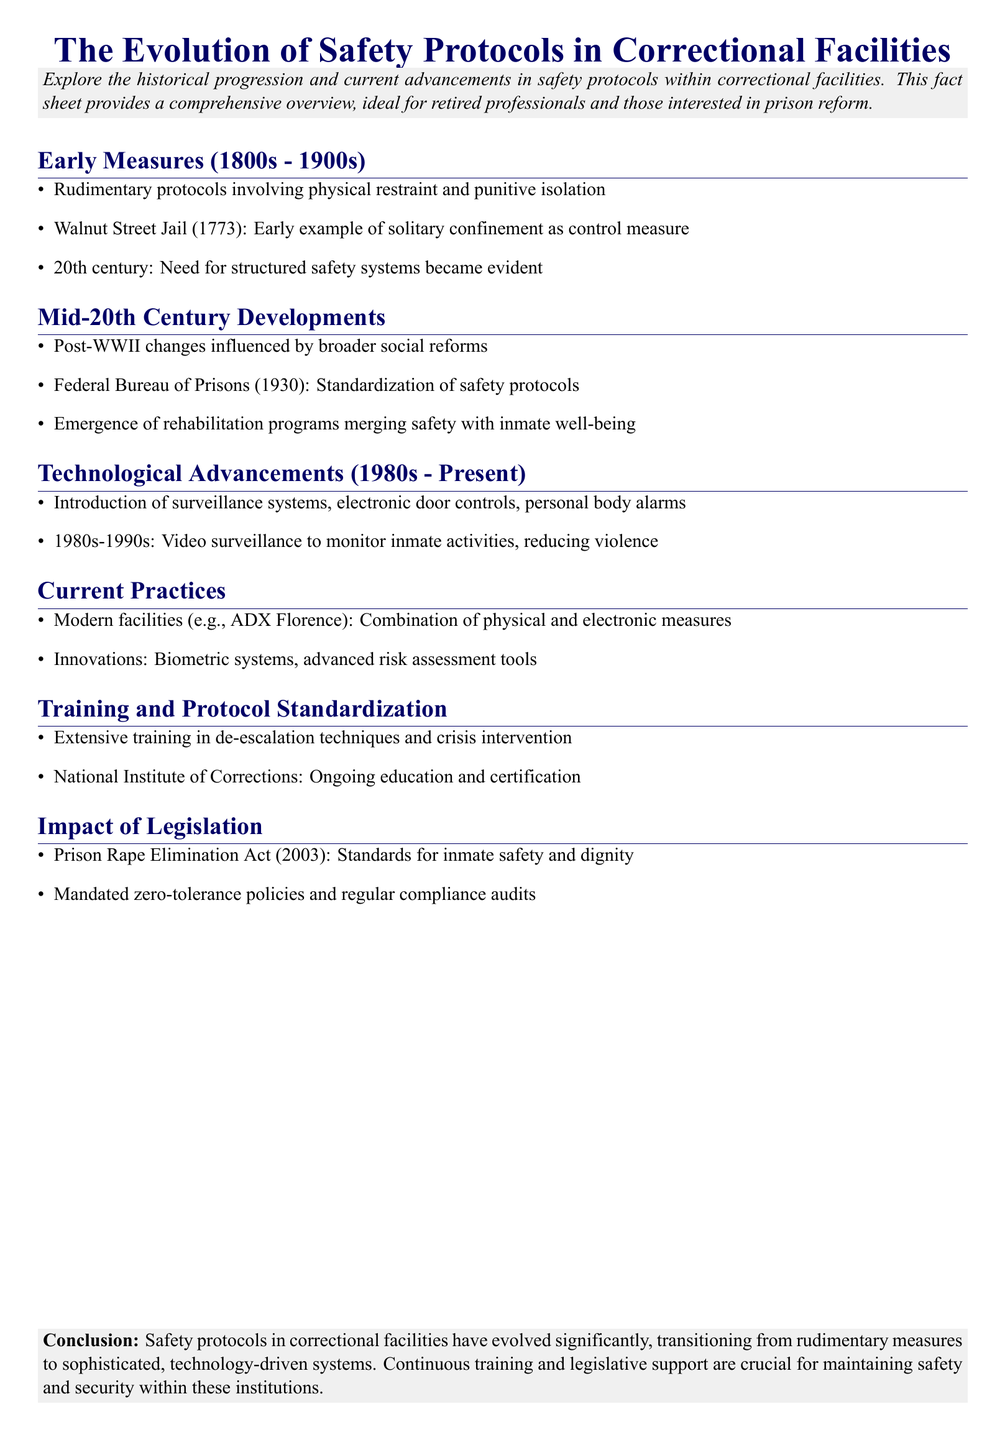What year was the Federal Bureau of Prisons established? The establishment of the Federal Bureau of Prisons is mentioned in the mid-20th century developments section, which states it was created in 1930.
Answer: 1930 What significant act was passed in 2003 regarding inmate safety? The document mentions the Prison Rape Elimination Act, which sets standards for inmate safety and dignity.
Answer: Prison Rape Elimination Act What type of training is emphasized for correctional officers? The document highlights extensive training in de-escalation techniques and crisis intervention as crucial for correctional officers.
Answer: De-escalation techniques In what century did the need for structured safety systems in correctional facilities become evident? This information is found in the early measures section, which notes that the need was evident in the 20th century.
Answer: 20th century What technological advancements were introduced in correctional facilities during the 1980s to present? The document lists surveillance systems, electronic door controls, and personal body alarms as technological advancements introduced in this period.
Answer: Surveillance systems What does ADX Florence represent in the context of current practices? The reference to ADX Florence indicates an example of modern correctional facilities that utilize a combination of physical and electronic safety measures.
Answer: Modern facilities What is the role of the National Institute of Corrections? The document states that the National Institute of Corrections provides ongoing education and certification for correctional officers.
Answer: Ongoing education and certification What was the primary measure used in correctional facilities during the 1800s? The early measures section mentions that physical restraint and punitive isolation were rudimentary protocols used during that time.
Answer: Physical restraint and punitive isolation What is a notable innovation mentioned for modern safety protocols? The document identifies biometric systems and advanced risk assessment tools as innovations in modern safety protocols within correctional facilities.
Answer: Biometric systems 